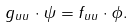<formula> <loc_0><loc_0><loc_500><loc_500>g _ { u u } \cdot \psi = f _ { u u } \cdot \phi .</formula> 